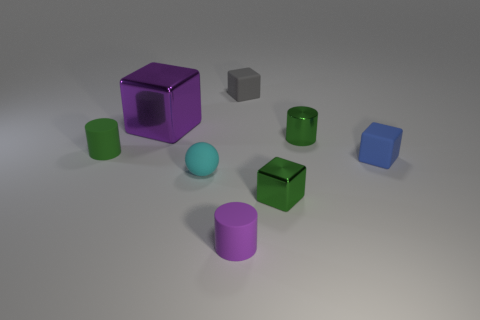There is a sphere that is the same size as the gray rubber block; what is it made of?
Your response must be concise. Rubber. Do the tiny blue rubber object that is right of the small green shiny cube and the tiny cyan matte object have the same shape?
Provide a succinct answer. No. Is the big cube the same color as the ball?
Make the answer very short. No. How many things are either things right of the small gray matte thing or small gray matte cubes?
Your answer should be very brief. 4. What is the shape of the blue rubber thing that is the same size as the purple rubber cylinder?
Provide a short and direct response. Cube. There is a cylinder that is in front of the small matte ball; is its size the same as the blue thing in front of the tiny green rubber cylinder?
Give a very brief answer. Yes. What color is the other cube that is made of the same material as the large cube?
Your answer should be compact. Green. Do the small cylinder on the right side of the tiny shiny cube and the cylinder on the left side of the cyan object have the same material?
Your answer should be very brief. No. Is there a brown rubber thing of the same size as the purple metal thing?
Keep it short and to the point. No. There is a green thing that is to the left of the rubber cylinder that is in front of the green cube; what size is it?
Provide a short and direct response. Small. 